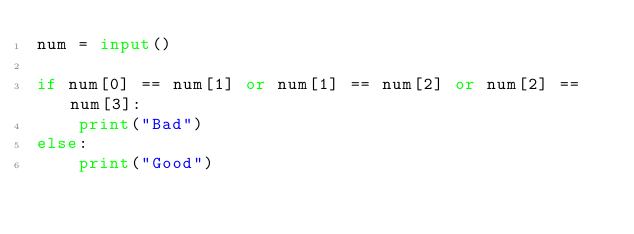Convert code to text. <code><loc_0><loc_0><loc_500><loc_500><_Python_>num = input()

if num[0] == num[1] or num[1] == num[2] or num[2] == num[3]:
    print("Bad")
else:
    print("Good")
</code> 